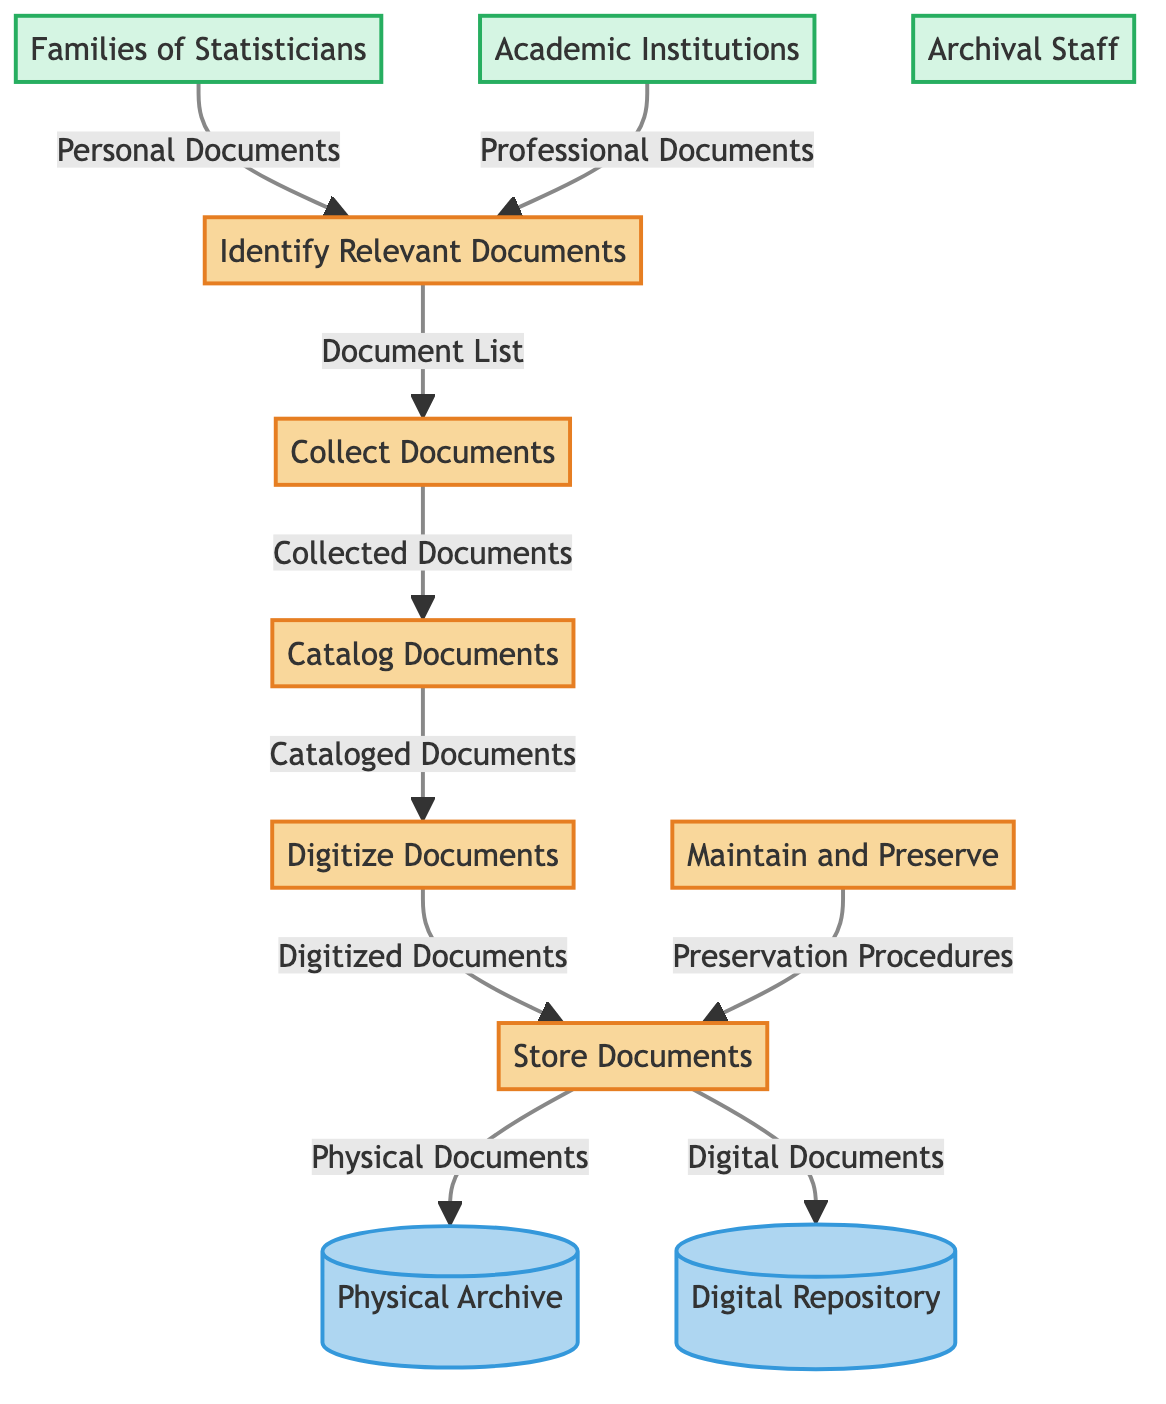What are the two types of documents identified in the process? The diagram indicates that the two types of documents are "Personal Documents" and "Professional Documents," as specified by the external entities that flow into the "Identify Relevant Documents" process.
Answer: Personal Documents, Professional Documents How many processes are there in the diagram? By counting the labeled processes from "Identify Relevant Documents" to "Maintain and Preserve," there are a total of six processes listed in the diagram.
Answer: 6 Which external entity contributes personal documents? The external entity that contributes personal documents to the process is labeled "Families of Statisticians" in the diagram.
Answer: Families of Statisticians What flow comes from "Digitize Documents" to "Store Documents"? The flow that comes from the "Digitize Documents" process to the "Store Documents" process is labeled "Digitized Documents," indicating the output from digitizing.
Answer: Digitized Documents What is the destination of the flow labeled "Physical Documents"? The "Physical Documents" flow goes directly to the "Physical Archive," indicating where physical copies of the collected documents are stored.
Answer: Physical Archive How do the "Maintain and Preserve" process and "Store Documents" interact? The interaction is denoted by the flow labeled "Preservation Procedures" that goes from "Maintain and Preserve" to "Store Documents," indicating that the maintenance process informs the storage process for preservation.
Answer: Preservation Procedures Which process precedes the "Catalog Documents" process? The process that precedes "Catalog Documents" is "Collect Documents," as indicated by the directed flow connecting the two processes.
Answer: Collect Documents What is stored in the Digital Repository? The Digital Repository stores documents labeled as "Digital Documents," which are the outcomes of the "Store Documents" process.
Answer: Digital Documents 